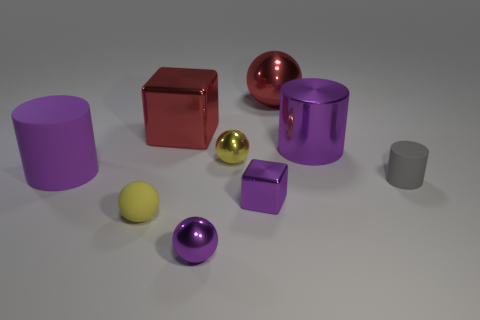What time of day does the lighting in the image suggest? The lighting in the image is diffuse and does not suggest a specific time of day. It seems to be more indicative of studio lighting used in a controlled environment for photography or rendering. 